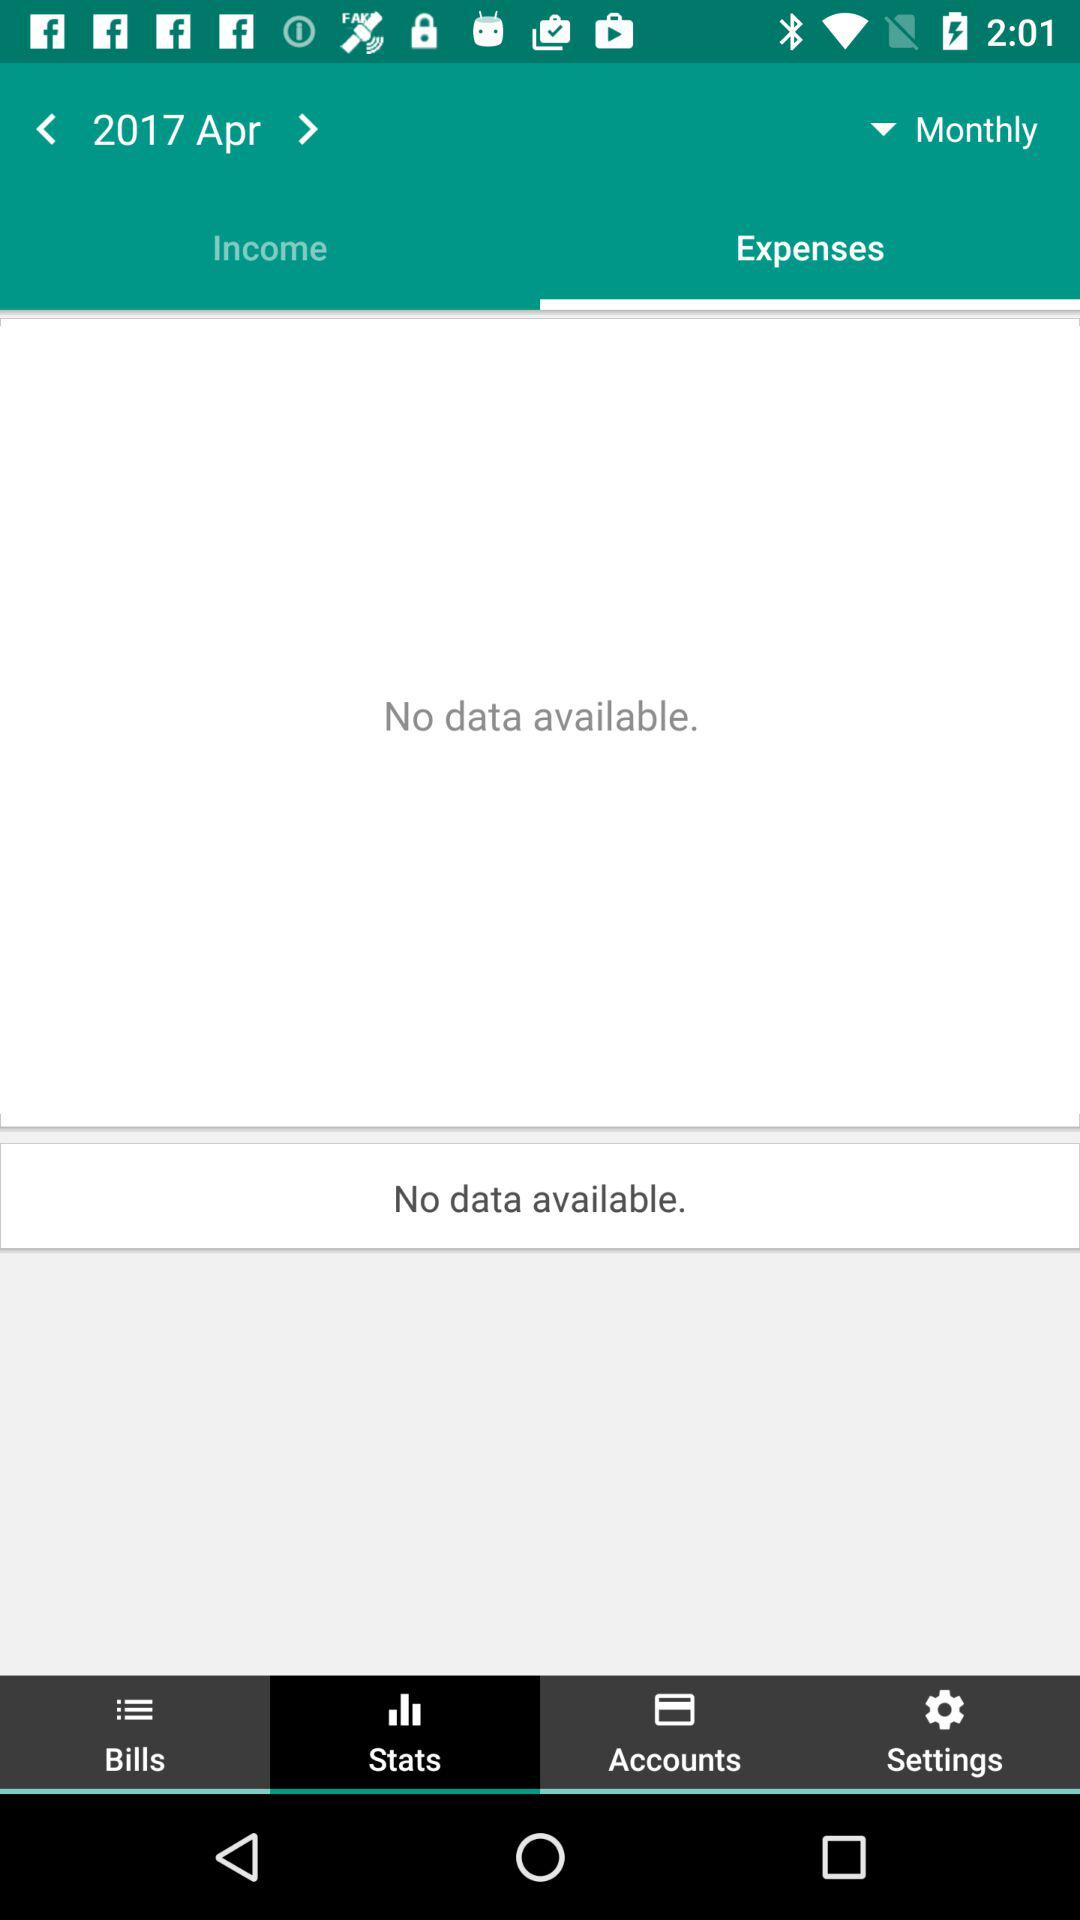What year and month have been selected? The selected year is 2017 and the month is April. 